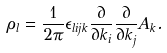Convert formula to latex. <formula><loc_0><loc_0><loc_500><loc_500>\rho _ { l } = \frac { 1 } { 2 \pi } \epsilon _ { l i j k } \frac { \partial } { \partial k _ { i } } \frac { \partial } { \partial k _ { j } } A _ { k } .</formula> 